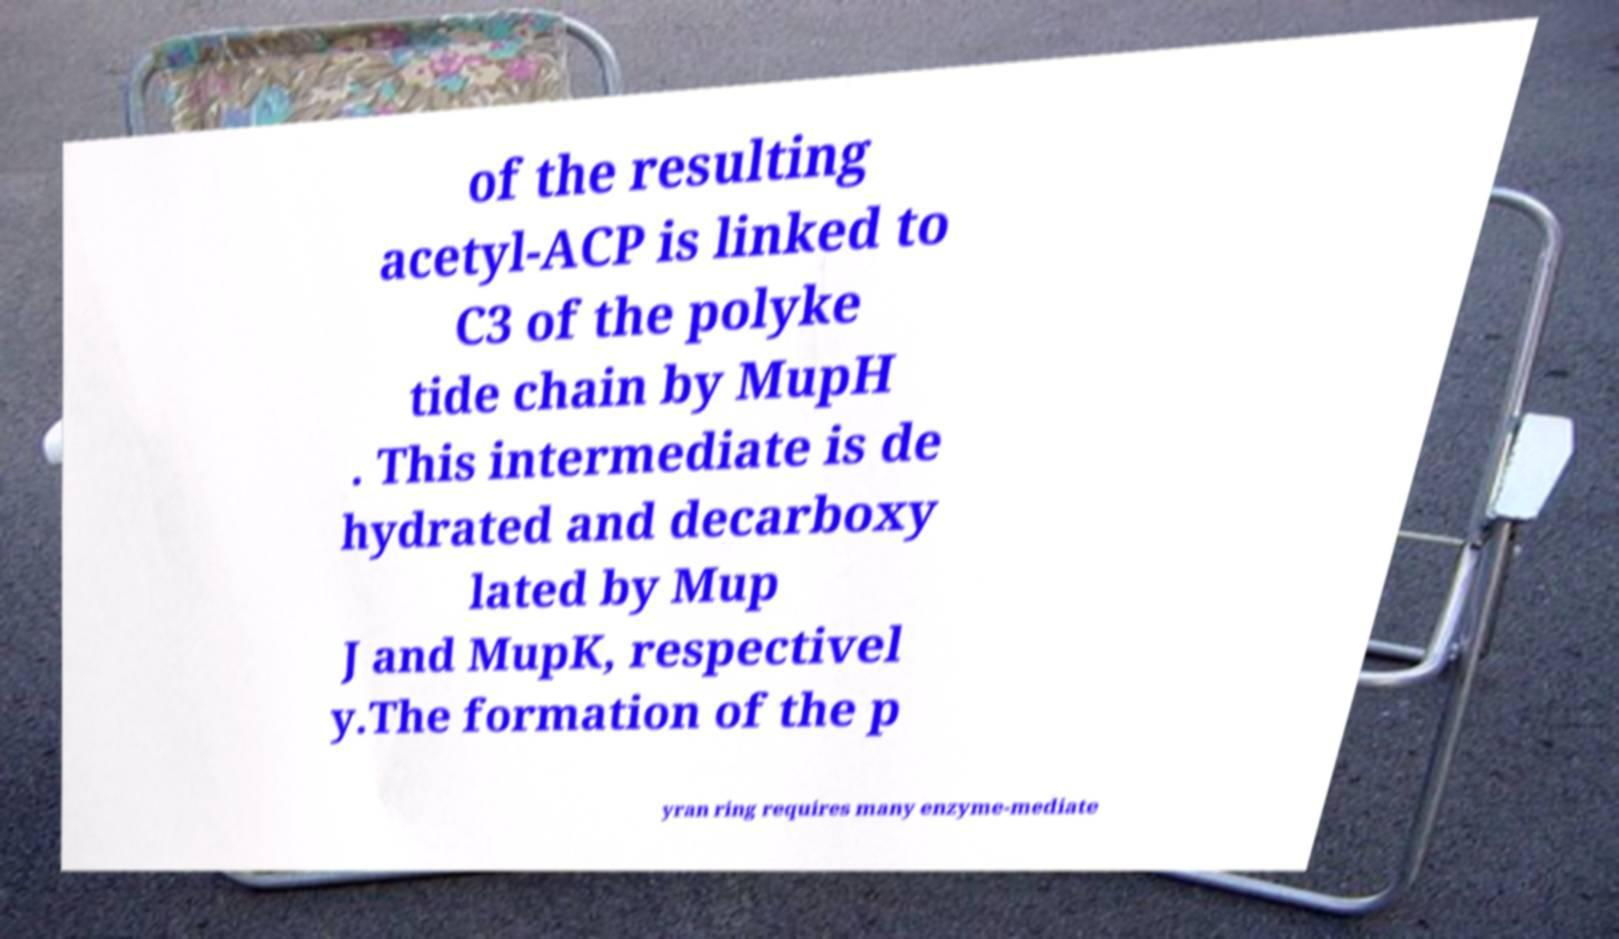I need the written content from this picture converted into text. Can you do that? of the resulting acetyl-ACP is linked to C3 of the polyke tide chain by MupH . This intermediate is de hydrated and decarboxy lated by Mup J and MupK, respectivel y.The formation of the p yran ring requires many enzyme-mediate 